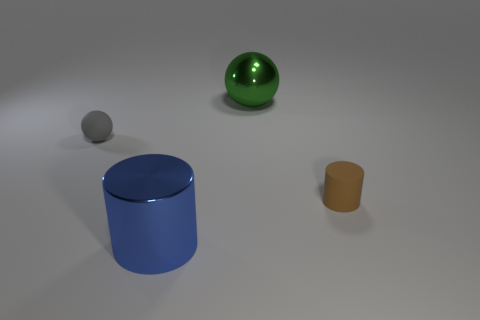Add 1 green metallic spheres. How many objects exist? 5 Subtract all blue cylinders. How many cylinders are left? 1 Subtract 0 cyan cylinders. How many objects are left? 4 Subtract all yellow cylinders. Subtract all red spheres. How many cylinders are left? 2 Subtract all small brown matte things. Subtract all big green shiny objects. How many objects are left? 2 Add 2 gray objects. How many gray objects are left? 3 Add 4 small gray metallic blocks. How many small gray metallic blocks exist? 4 